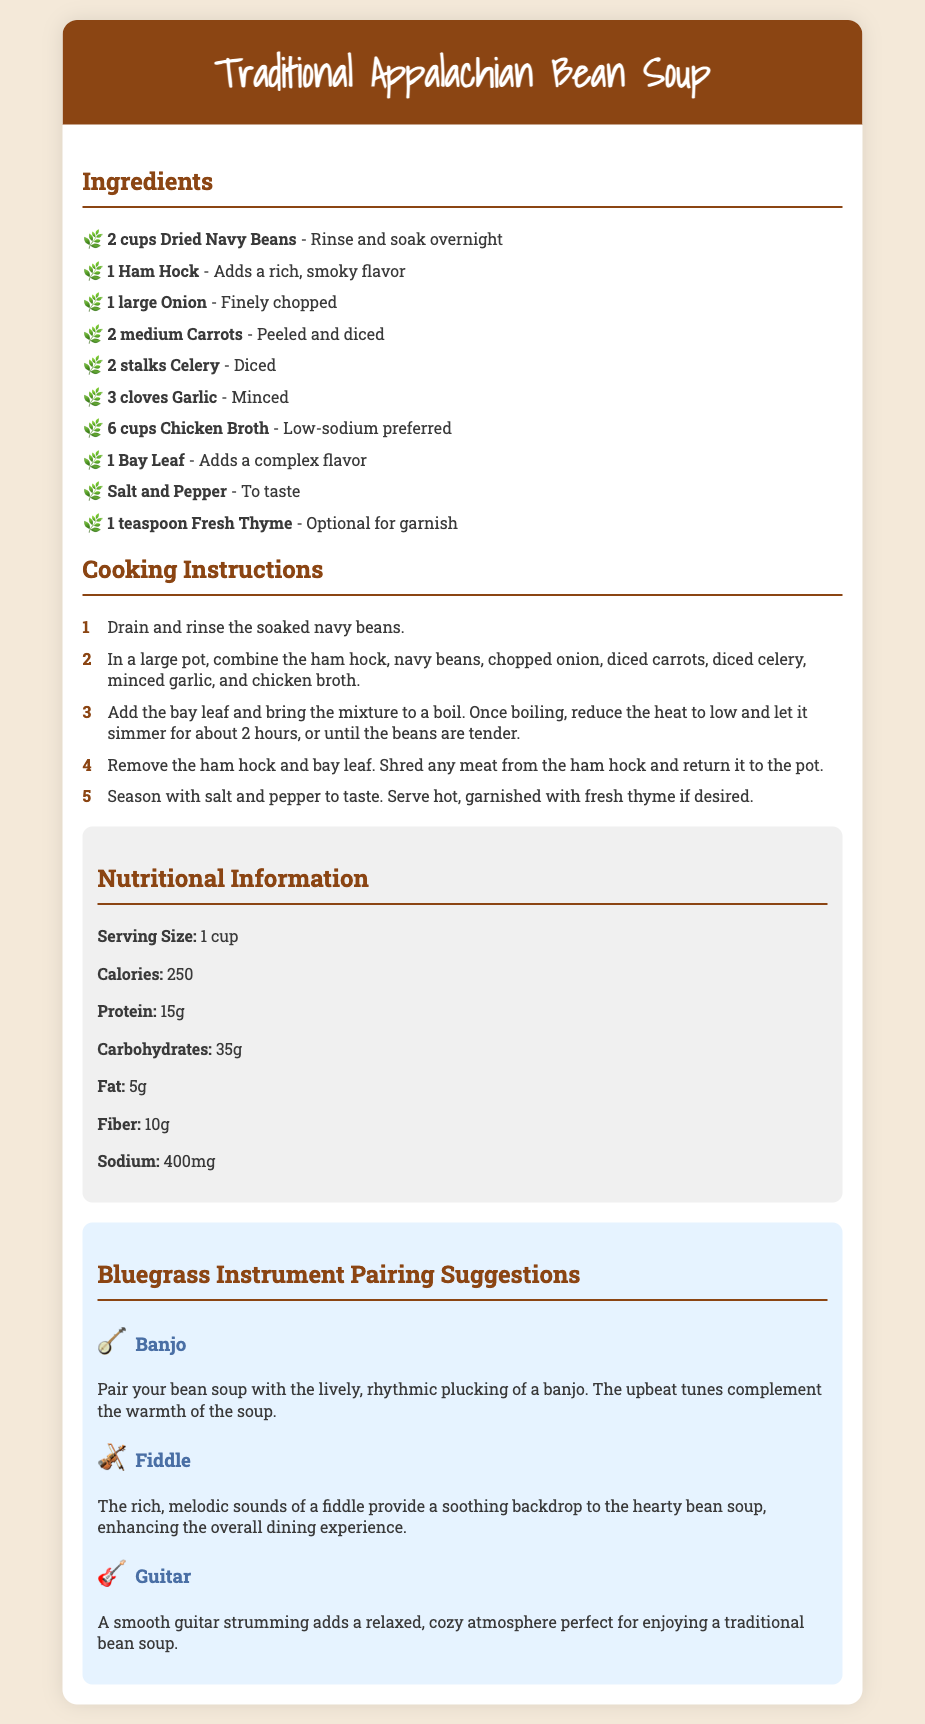What are the main ingredients for the soup? The main ingredients are listed in the Ingredients section of the document.
Answer: Dried Navy Beans, Ham Hock, Onion, Carrots, Celery, Garlic, Chicken Broth, Bay Leaf, Salt, Pepper, Fresh Thyme How long should the beans be soaked? The soaking time is mentioned at the beginning of the Ingredients list.
Answer: Overnight What is the cooking time for the soup? The cooking time is specified in the Cooking Instructions section, outlining how long to simmer.
Answer: About 2 hours What is the serving size for the soup? The serving size is provided in the Nutritional Information section.
Answer: 1 cup Which bluegrass instrument pairs well with the soup for an upbeat atmosphere? The pairing suggestions include instruments that enhance the experience of dining on the soup.
Answer: Banjo How many grams of protein are in one serving? The protein content is found in the Nutritional Information section of the document.
Answer: 15g What do you do with the ham hock after cooking? The instructions specify what to do with the ham hock in the Cooking Instructions section.
Answer: Shred any meat from the ham hock and return it to the pot What is listed as optional for garnish? The document specifies optional ingredients in the Ingredients section.
Answer: Fresh Thyme Which instrument adds a relaxed atmosphere to the meal? The document suggests specific instruments for pairing with the soup.
Answer: Guitar 